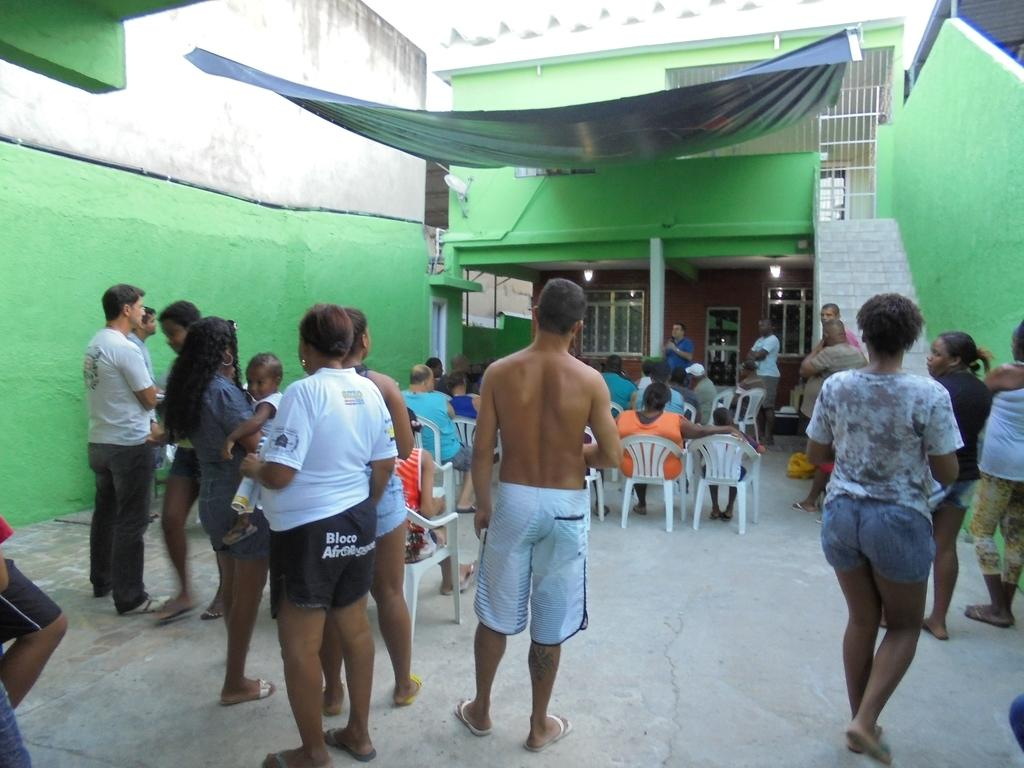How many people are in the image? There is a group of people in the image. What are some of the people in the image doing? Some people are sitting on chairs. What color is the wall in the image? The wall is green. What can be seen in the distance in the image? There is a pillar, windows, and lights visible in the distance. What letters are being spelled out by the donkey in the image? There is no donkey present in the image, and therefore no letters being spelled out. How many pins are visible on the wall in the image? There is no mention of pins in the image; the wall is simply described as green. 